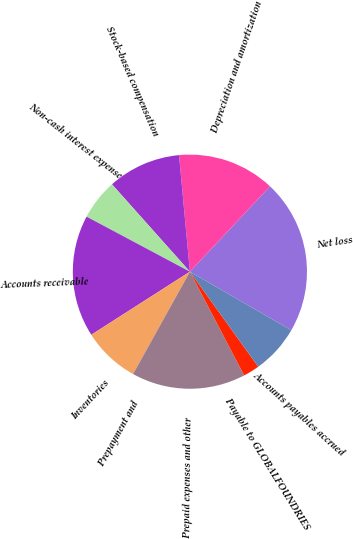Convert chart to OTSL. <chart><loc_0><loc_0><loc_500><loc_500><pie_chart><fcel>Net loss<fcel>Depreciation and amortization<fcel>Stock-based compensation<fcel>Non-cash interest expense<fcel>Accounts receivable<fcel>Inventories<fcel>Prepayment and<fcel>Prepaid expenses and other<fcel>Payable to GLOBALFOUNDRIES<fcel>Accounts payables accrued<nl><fcel>21.34%<fcel>13.48%<fcel>10.11%<fcel>5.62%<fcel>16.85%<fcel>7.87%<fcel>0.01%<fcel>15.73%<fcel>2.25%<fcel>6.74%<nl></chart> 